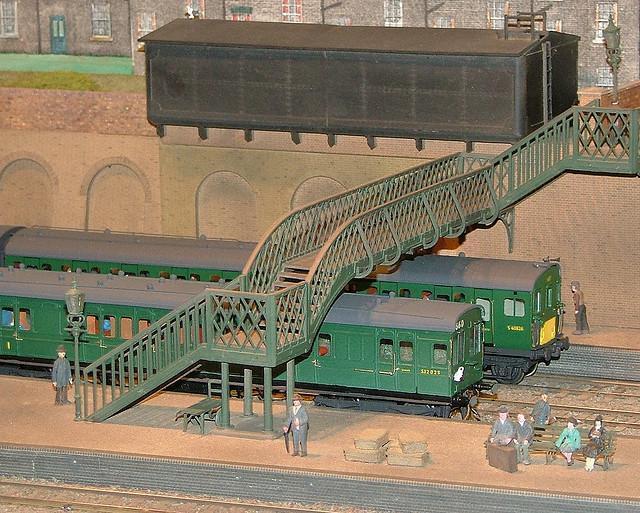What type of trains are shown here?
Answer the question by selecting the correct answer among the 4 following choices.
Options: Miniature, electric, tram, diesel. Miniature. 